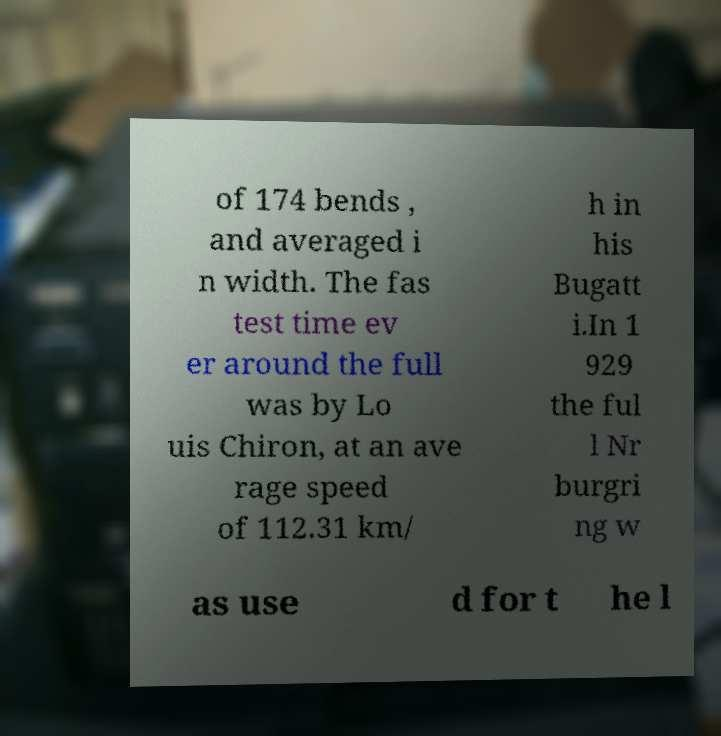For documentation purposes, I need the text within this image transcribed. Could you provide that? of 174 bends , and averaged i n width. The fas test time ev er around the full was by Lo uis Chiron, at an ave rage speed of 112.31 km/ h in his Bugatt i.In 1 929 the ful l Nr burgri ng w as use d for t he l 